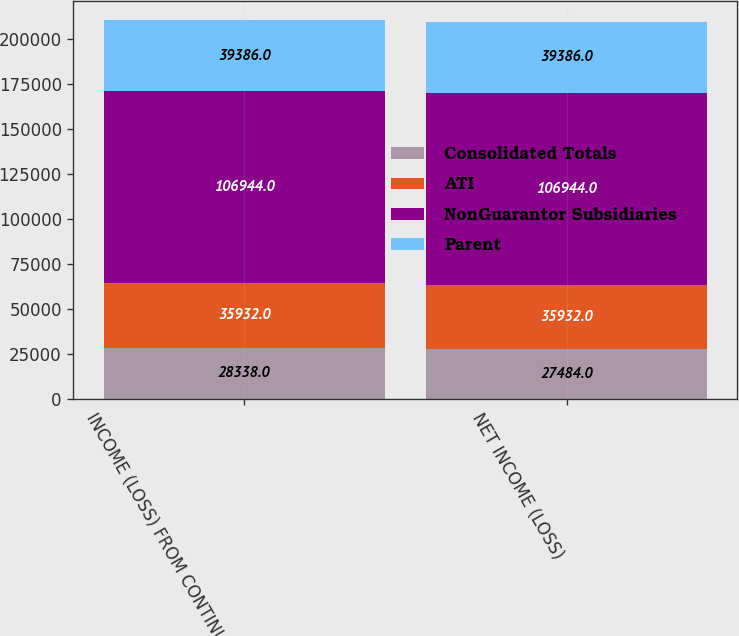Convert chart. <chart><loc_0><loc_0><loc_500><loc_500><stacked_bar_chart><ecel><fcel>INCOME (LOSS) FROM CONTINUING<fcel>NET INCOME (LOSS)<nl><fcel>Consolidated Totals<fcel>28338<fcel>27484<nl><fcel>ATI<fcel>35932<fcel>35932<nl><fcel>NonGuarantor Subsidiaries<fcel>106944<fcel>106944<nl><fcel>Parent<fcel>39386<fcel>39386<nl></chart> 